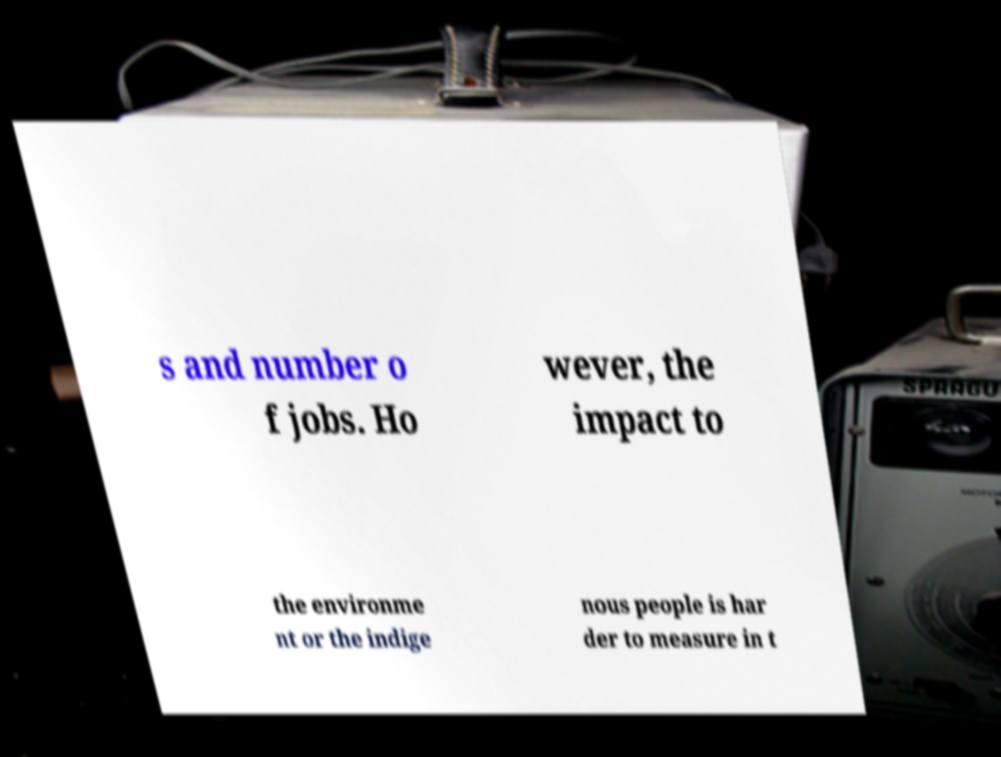Could you extract and type out the text from this image? s and number o f jobs. Ho wever, the impact to the environme nt or the indige nous people is har der to measure in t 